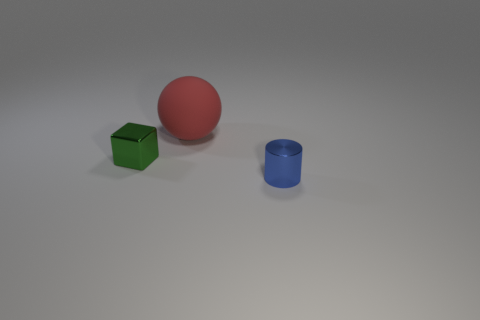Is there anything else that is the same size as the rubber ball?
Your answer should be compact. No. Are there more small blue metal things that are on the left side of the tiny cube than tiny blue cylinders?
Offer a very short reply. No. The block that is made of the same material as the small blue object is what size?
Give a very brief answer. Small. There is a red ball; are there any red rubber things behind it?
Give a very brief answer. No. Do the green object and the large red rubber thing have the same shape?
Provide a short and direct response. No. How big is the object that is to the right of the large red rubber ball that is on the left side of the tiny thing that is right of the green object?
Provide a succinct answer. Small. What is the material of the tiny blue cylinder?
Your answer should be compact. Metal. There is a tiny green object; does it have the same shape as the object to the right of the red rubber object?
Your answer should be very brief. No. What material is the tiny blue cylinder right of the tiny object that is behind the thing that is right of the ball made of?
Give a very brief answer. Metal. What number of tiny shiny blocks are there?
Make the answer very short. 1. 